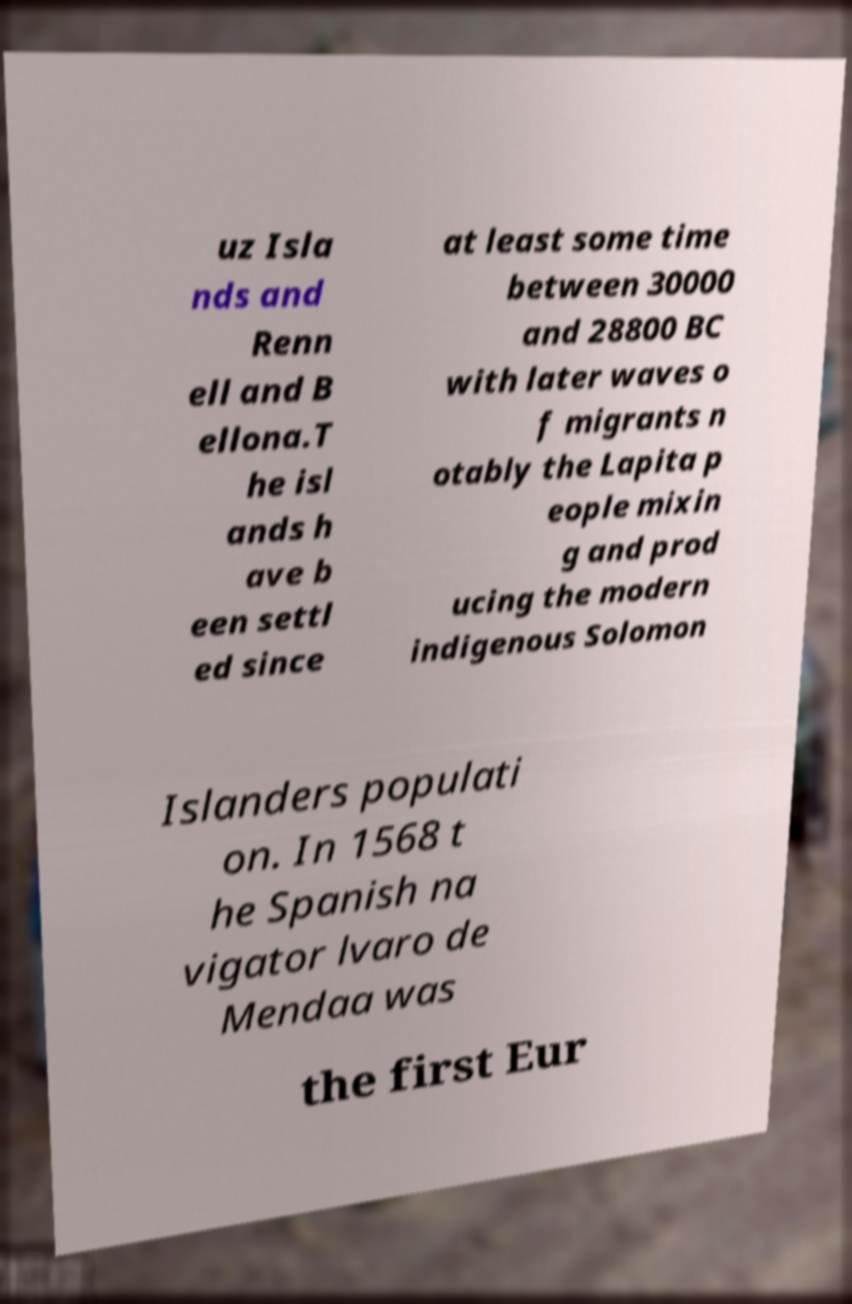There's text embedded in this image that I need extracted. Can you transcribe it verbatim? uz Isla nds and Renn ell and B ellona.T he isl ands h ave b een settl ed since at least some time between 30000 and 28800 BC with later waves o f migrants n otably the Lapita p eople mixin g and prod ucing the modern indigenous Solomon Islanders populati on. In 1568 t he Spanish na vigator lvaro de Mendaa was the first Eur 